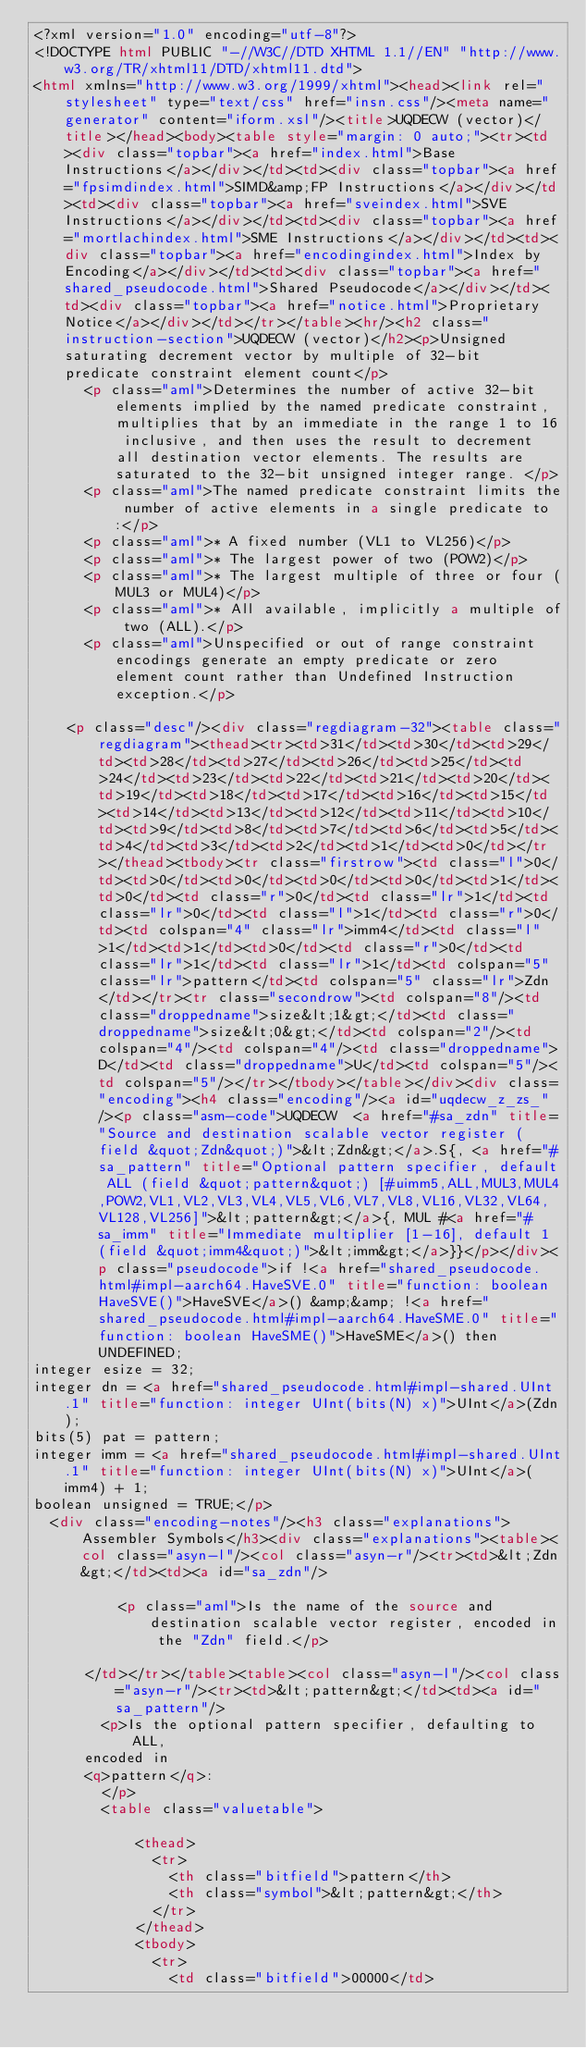Convert code to text. <code><loc_0><loc_0><loc_500><loc_500><_HTML_><?xml version="1.0" encoding="utf-8"?>
<!DOCTYPE html PUBLIC "-//W3C//DTD XHTML 1.1//EN" "http://www.w3.org/TR/xhtml11/DTD/xhtml11.dtd">
<html xmlns="http://www.w3.org/1999/xhtml"><head><link rel="stylesheet" type="text/css" href="insn.css"/><meta name="generator" content="iform.xsl"/><title>UQDECW (vector)</title></head><body><table style="margin: 0 auto;"><tr><td><div class="topbar"><a href="index.html">Base Instructions</a></div></td><td><div class="topbar"><a href="fpsimdindex.html">SIMD&amp;FP Instructions</a></div></td><td><div class="topbar"><a href="sveindex.html">SVE Instructions</a></div></td><td><div class="topbar"><a href="mortlachindex.html">SME Instructions</a></div></td><td><div class="topbar"><a href="encodingindex.html">Index by Encoding</a></div></td><td><div class="topbar"><a href="shared_pseudocode.html">Shared Pseudocode</a></div></td><td><div class="topbar"><a href="notice.html">Proprietary Notice</a></div></td></tr></table><hr/><h2 class="instruction-section">UQDECW (vector)</h2><p>Unsigned saturating decrement vector by multiple of 32-bit predicate constraint element count</p>
      <p class="aml">Determines the number of active 32-bit elements implied by the named predicate constraint, multiplies that by an immediate in the range 1 to 16 inclusive, and then uses the result to decrement all destination vector elements. The results are saturated to the 32-bit unsigned integer range. </p>
      <p class="aml">The named predicate constraint limits the number of active elements in a single predicate to:</p>
      <p class="aml">* A fixed number (VL1 to VL256)</p>
      <p class="aml">* The largest power of two (POW2)</p>
      <p class="aml">* The largest multiple of three or four (MUL3 or MUL4)</p>
      <p class="aml">* All available, implicitly a multiple of two (ALL).</p>
      <p class="aml">Unspecified or out of range constraint encodings generate an empty predicate or zero element count rather than Undefined Instruction exception.</p>
    
    <p class="desc"/><div class="regdiagram-32"><table class="regdiagram"><thead><tr><td>31</td><td>30</td><td>29</td><td>28</td><td>27</td><td>26</td><td>25</td><td>24</td><td>23</td><td>22</td><td>21</td><td>20</td><td>19</td><td>18</td><td>17</td><td>16</td><td>15</td><td>14</td><td>13</td><td>12</td><td>11</td><td>10</td><td>9</td><td>8</td><td>7</td><td>6</td><td>5</td><td>4</td><td>3</td><td>2</td><td>1</td><td>0</td></tr></thead><tbody><tr class="firstrow"><td class="l">0</td><td>0</td><td>0</td><td>0</td><td>0</td><td>1</td><td>0</td><td class="r">0</td><td class="lr">1</td><td class="lr">0</td><td class="l">1</td><td class="r">0</td><td colspan="4" class="lr">imm4</td><td class="l">1</td><td>1</td><td>0</td><td class="r">0</td><td class="lr">1</td><td class="lr">1</td><td colspan="5" class="lr">pattern</td><td colspan="5" class="lr">Zdn</td></tr><tr class="secondrow"><td colspan="8"/><td class="droppedname">size&lt;1&gt;</td><td class="droppedname">size&lt;0&gt;</td><td colspan="2"/><td colspan="4"/><td colspan="4"/><td class="droppedname">D</td><td class="droppedname">U</td><td colspan="5"/><td colspan="5"/></tr></tbody></table></div><div class="encoding"><h4 class="encoding"/><a id="uqdecw_z_zs_"/><p class="asm-code">UQDECW  <a href="#sa_zdn" title="Source and destination scalable vector register (field &quot;Zdn&quot;)">&lt;Zdn&gt;</a>.S{, <a href="#sa_pattern" title="Optional pattern specifier, default ALL (field &quot;pattern&quot;) [#uimm5,ALL,MUL3,MUL4,POW2,VL1,VL2,VL3,VL4,VL5,VL6,VL7,VL8,VL16,VL32,VL64,VL128,VL256]">&lt;pattern&gt;</a>{, MUL #<a href="#sa_imm" title="Immediate multiplier [1-16], default 1 (field &quot;imm4&quot;)">&lt;imm&gt;</a>}}</p></div><p class="pseudocode">if !<a href="shared_pseudocode.html#impl-aarch64.HaveSVE.0" title="function: boolean HaveSVE()">HaveSVE</a>() &amp;&amp; !<a href="shared_pseudocode.html#impl-aarch64.HaveSME.0" title="function: boolean HaveSME()">HaveSME</a>() then UNDEFINED;
integer esize = 32;
integer dn = <a href="shared_pseudocode.html#impl-shared.UInt.1" title="function: integer UInt(bits(N) x)">UInt</a>(Zdn);
bits(5) pat = pattern;
integer imm = <a href="shared_pseudocode.html#impl-shared.UInt.1" title="function: integer UInt(bits(N) x)">UInt</a>(imm4) + 1;
boolean unsigned = TRUE;</p>
  <div class="encoding-notes"/><h3 class="explanations">Assembler Symbols</h3><div class="explanations"><table><col class="asyn-l"/><col class="asyn-r"/><tr><td>&lt;Zdn&gt;</td><td><a id="sa_zdn"/>
        
          <p class="aml">Is the name of the source and destination scalable vector register, encoded in the "Zdn" field.</p>
        
      </td></tr></table><table><col class="asyn-l"/><col class="asyn-r"/><tr><td>&lt;pattern&gt;</td><td><a id="sa_pattern"/>
        <p>Is the optional pattern specifier, defaulting to ALL, 
      encoded in
      <q>pattern</q>:
        </p>
        <table class="valuetable">
          
            <thead>
              <tr>
                <th class="bitfield">pattern</th>
                <th class="symbol">&lt;pattern&gt;</th>
              </tr>
            </thead>
            <tbody>
              <tr>
                <td class="bitfield">00000</td></code> 